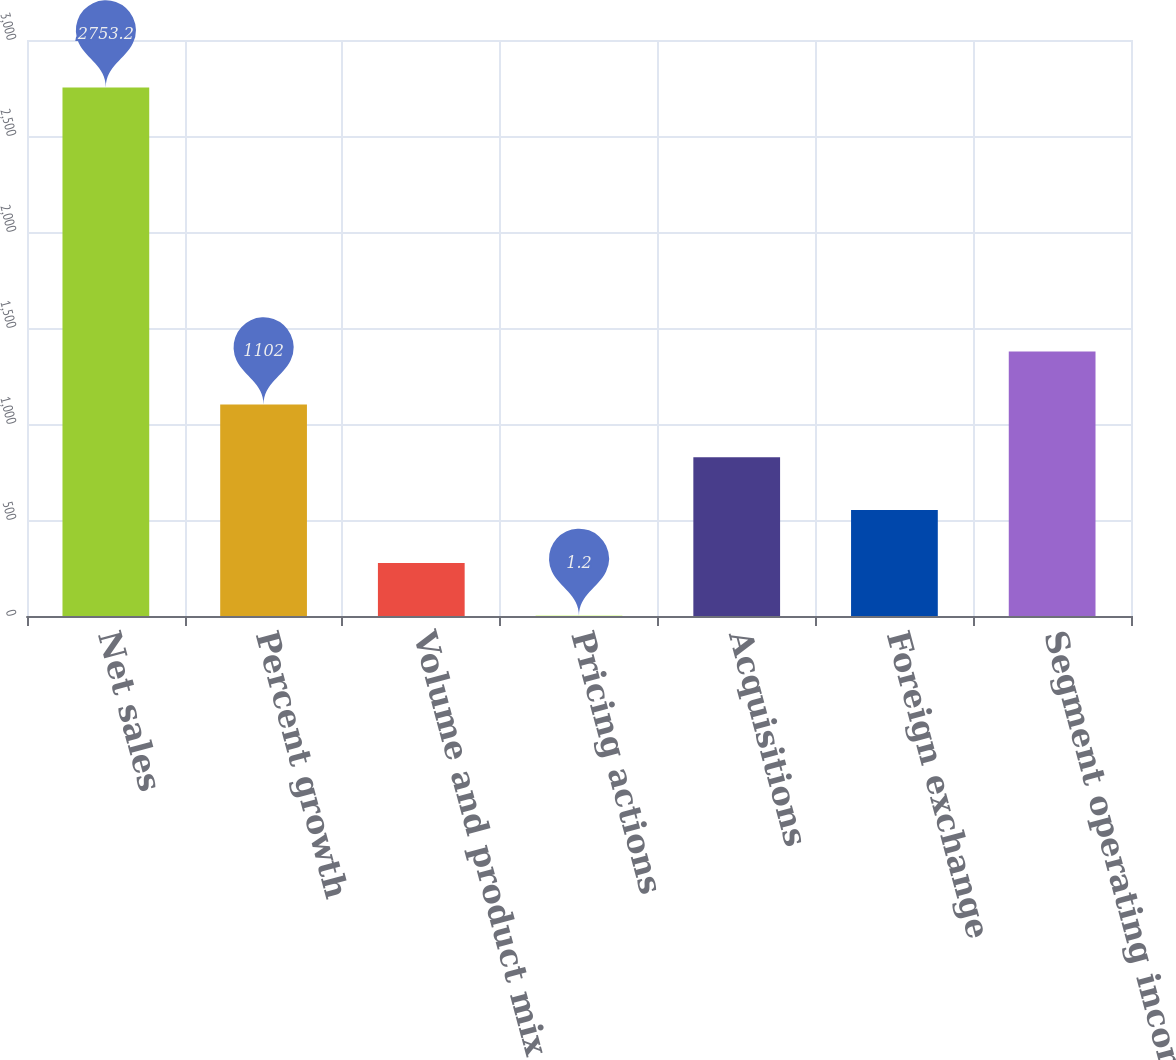Convert chart to OTSL. <chart><loc_0><loc_0><loc_500><loc_500><bar_chart><fcel>Net sales<fcel>Percent growth<fcel>Volume and product mix<fcel>Pricing actions<fcel>Acquisitions<fcel>Foreign exchange<fcel>Segment operating income<nl><fcel>2753.2<fcel>1102<fcel>276.4<fcel>1.2<fcel>826.8<fcel>551.6<fcel>1377.2<nl></chart> 